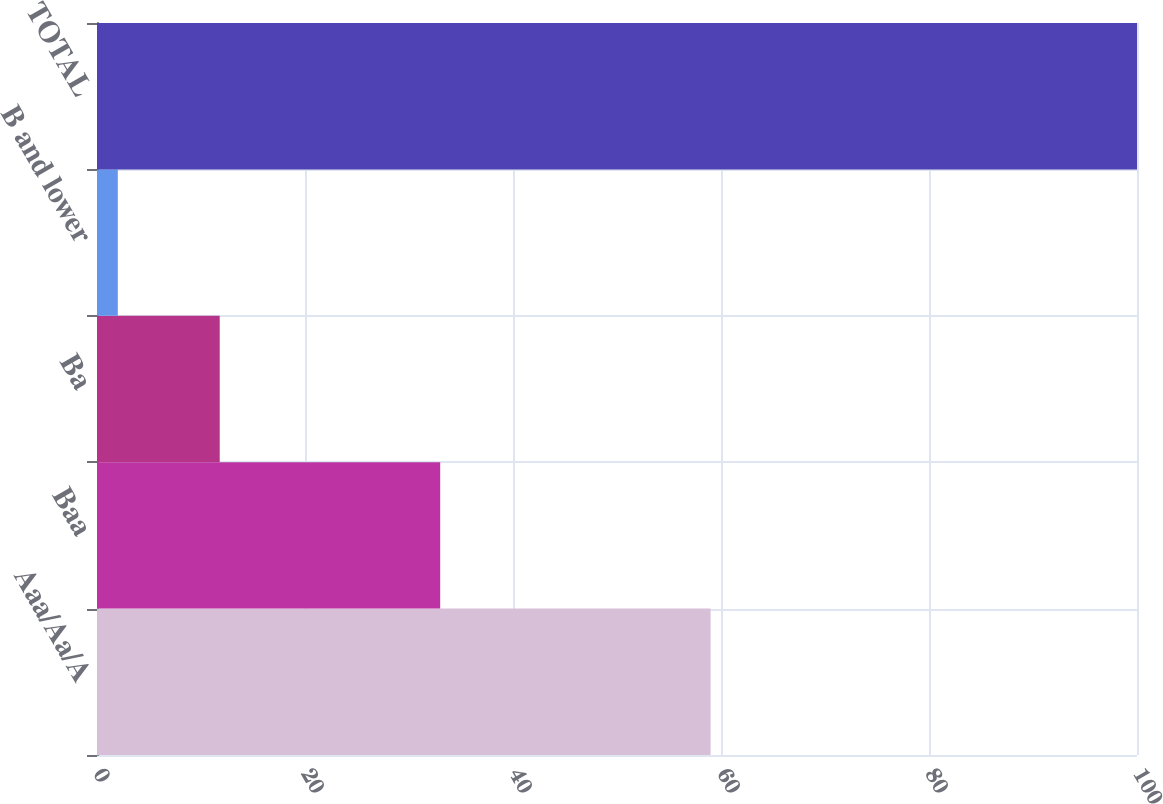<chart> <loc_0><loc_0><loc_500><loc_500><bar_chart><fcel>Aaa/Aa/A<fcel>Baa<fcel>Ba<fcel>B and lower<fcel>TOTAL<nl><fcel>59<fcel>33<fcel>11.8<fcel>2<fcel>100<nl></chart> 